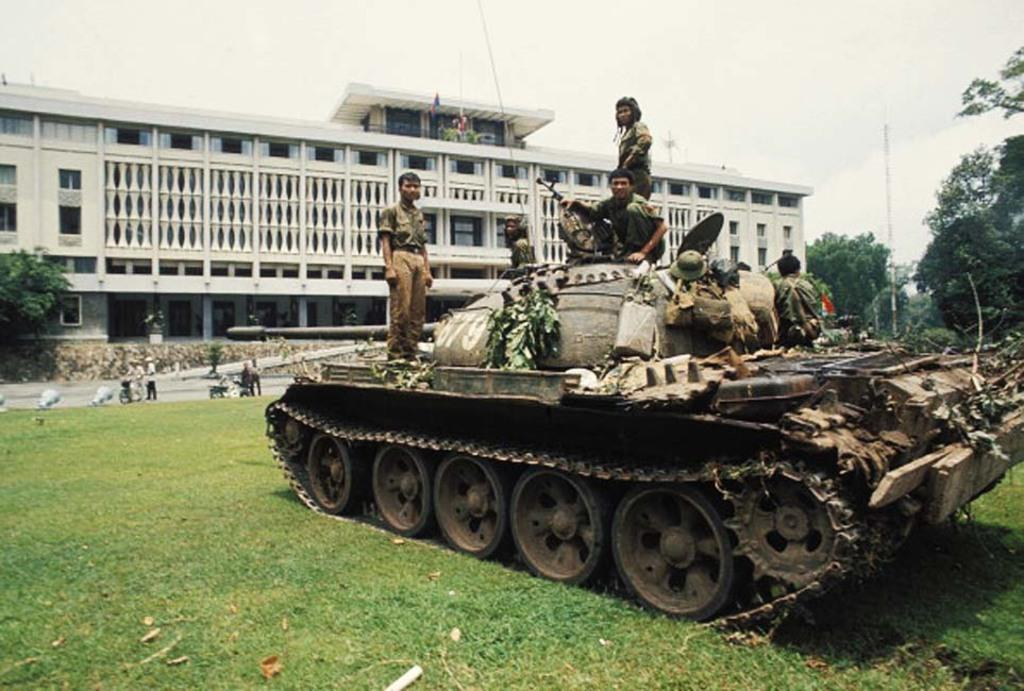Who or what can be seen in the image? There are people in the image. What is located on the grass in the image? There is a military tank on the grass. What can be seen in the background of the image? There is a building, a pole, trees, and the sky visible in the background of the image. What type of shop can be seen in the image? There is no shop present in the image. Can you recite a verse from the poem that is visible in the image? There is no poem or verse present in the image. 